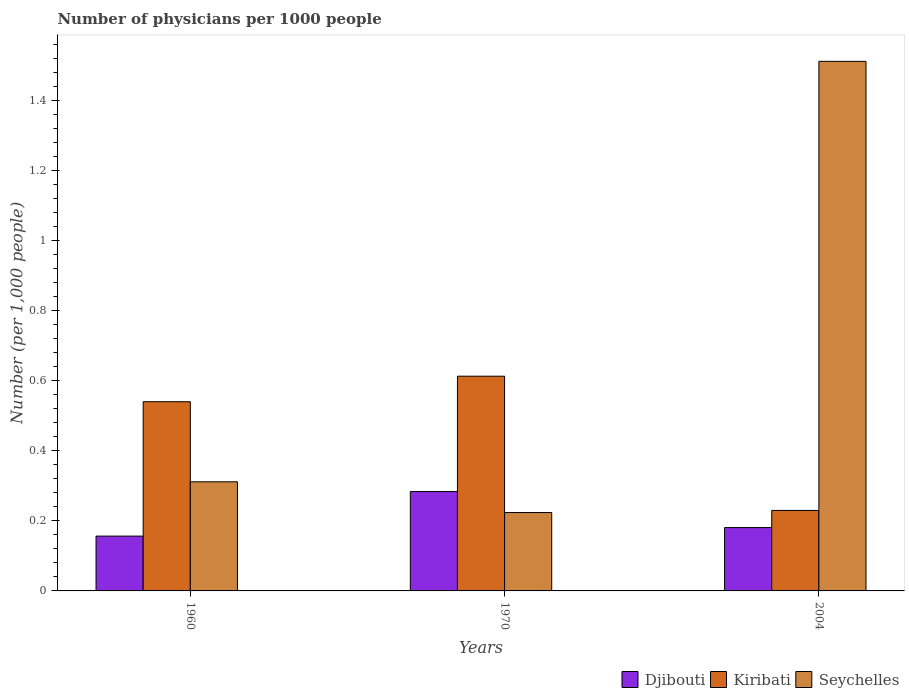How many different coloured bars are there?
Your answer should be compact. 3. How many groups of bars are there?
Provide a short and direct response. 3. Are the number of bars per tick equal to the number of legend labels?
Give a very brief answer. Yes. What is the label of the 3rd group of bars from the left?
Make the answer very short. 2004. What is the number of physicians in Seychelles in 1970?
Offer a terse response. 0.22. Across all years, what is the maximum number of physicians in Seychelles?
Provide a short and direct response. 1.51. Across all years, what is the minimum number of physicians in Seychelles?
Your response must be concise. 0.22. In which year was the number of physicians in Kiribati maximum?
Keep it short and to the point. 1970. What is the total number of physicians in Djibouti in the graph?
Make the answer very short. 0.62. What is the difference between the number of physicians in Kiribati in 1960 and that in 1970?
Offer a terse response. -0.07. What is the difference between the number of physicians in Djibouti in 1970 and the number of physicians in Kiribati in 2004?
Provide a succinct answer. 0.05. What is the average number of physicians in Djibouti per year?
Provide a short and direct response. 0.21. In the year 1970, what is the difference between the number of physicians in Seychelles and number of physicians in Kiribati?
Provide a short and direct response. -0.39. In how many years, is the number of physicians in Kiribati greater than 0.68?
Your response must be concise. 0. What is the ratio of the number of physicians in Seychelles in 1960 to that in 2004?
Your response must be concise. 0.21. Is the difference between the number of physicians in Seychelles in 1960 and 2004 greater than the difference between the number of physicians in Kiribati in 1960 and 2004?
Make the answer very short. No. What is the difference between the highest and the second highest number of physicians in Kiribati?
Your answer should be compact. 0.07. What is the difference between the highest and the lowest number of physicians in Seychelles?
Make the answer very short. 1.29. Is the sum of the number of physicians in Djibouti in 1970 and 2004 greater than the maximum number of physicians in Kiribati across all years?
Offer a very short reply. No. What does the 1st bar from the left in 1960 represents?
Provide a succinct answer. Djibouti. What does the 1st bar from the right in 1960 represents?
Your answer should be very brief. Seychelles. Is it the case that in every year, the sum of the number of physicians in Seychelles and number of physicians in Kiribati is greater than the number of physicians in Djibouti?
Give a very brief answer. Yes. Are all the bars in the graph horizontal?
Give a very brief answer. No. How many years are there in the graph?
Your answer should be very brief. 3. What is the difference between two consecutive major ticks on the Y-axis?
Provide a short and direct response. 0.2. Are the values on the major ticks of Y-axis written in scientific E-notation?
Your answer should be very brief. No. Does the graph contain any zero values?
Make the answer very short. No. Does the graph contain grids?
Your response must be concise. No. How many legend labels are there?
Provide a short and direct response. 3. How are the legend labels stacked?
Make the answer very short. Horizontal. What is the title of the graph?
Provide a succinct answer. Number of physicians per 1000 people. Does "World" appear as one of the legend labels in the graph?
Your answer should be compact. No. What is the label or title of the Y-axis?
Offer a very short reply. Number (per 1,0 people). What is the Number (per 1,000 people) in Djibouti in 1960?
Provide a short and direct response. 0.16. What is the Number (per 1,000 people) in Kiribati in 1960?
Ensure brevity in your answer.  0.54. What is the Number (per 1,000 people) of Seychelles in 1960?
Keep it short and to the point. 0.31. What is the Number (per 1,000 people) in Djibouti in 1970?
Offer a very short reply. 0.28. What is the Number (per 1,000 people) in Kiribati in 1970?
Your answer should be compact. 0.61. What is the Number (per 1,000 people) in Seychelles in 1970?
Give a very brief answer. 0.22. What is the Number (per 1,000 people) in Djibouti in 2004?
Offer a very short reply. 0.18. What is the Number (per 1,000 people) of Kiribati in 2004?
Give a very brief answer. 0.23. What is the Number (per 1,000 people) of Seychelles in 2004?
Provide a succinct answer. 1.51. Across all years, what is the maximum Number (per 1,000 people) in Djibouti?
Keep it short and to the point. 0.28. Across all years, what is the maximum Number (per 1,000 people) of Kiribati?
Keep it short and to the point. 0.61. Across all years, what is the maximum Number (per 1,000 people) in Seychelles?
Your answer should be compact. 1.51. Across all years, what is the minimum Number (per 1,000 people) of Djibouti?
Provide a succinct answer. 0.16. Across all years, what is the minimum Number (per 1,000 people) of Kiribati?
Your answer should be compact. 0.23. Across all years, what is the minimum Number (per 1,000 people) of Seychelles?
Give a very brief answer. 0.22. What is the total Number (per 1,000 people) of Djibouti in the graph?
Give a very brief answer. 0.62. What is the total Number (per 1,000 people) in Kiribati in the graph?
Your response must be concise. 1.38. What is the total Number (per 1,000 people) in Seychelles in the graph?
Offer a very short reply. 2.05. What is the difference between the Number (per 1,000 people) of Djibouti in 1960 and that in 1970?
Your answer should be very brief. -0.13. What is the difference between the Number (per 1,000 people) of Kiribati in 1960 and that in 1970?
Your response must be concise. -0.07. What is the difference between the Number (per 1,000 people) in Seychelles in 1960 and that in 1970?
Give a very brief answer. 0.09. What is the difference between the Number (per 1,000 people) of Djibouti in 1960 and that in 2004?
Ensure brevity in your answer.  -0.02. What is the difference between the Number (per 1,000 people) of Kiribati in 1960 and that in 2004?
Provide a short and direct response. 0.31. What is the difference between the Number (per 1,000 people) in Seychelles in 1960 and that in 2004?
Your answer should be compact. -1.2. What is the difference between the Number (per 1,000 people) in Djibouti in 1970 and that in 2004?
Ensure brevity in your answer.  0.1. What is the difference between the Number (per 1,000 people) of Kiribati in 1970 and that in 2004?
Make the answer very short. 0.38. What is the difference between the Number (per 1,000 people) in Seychelles in 1970 and that in 2004?
Offer a very short reply. -1.29. What is the difference between the Number (per 1,000 people) of Djibouti in 1960 and the Number (per 1,000 people) of Kiribati in 1970?
Make the answer very short. -0.46. What is the difference between the Number (per 1,000 people) in Djibouti in 1960 and the Number (per 1,000 people) in Seychelles in 1970?
Offer a very short reply. -0.07. What is the difference between the Number (per 1,000 people) in Kiribati in 1960 and the Number (per 1,000 people) in Seychelles in 1970?
Your response must be concise. 0.32. What is the difference between the Number (per 1,000 people) of Djibouti in 1960 and the Number (per 1,000 people) of Kiribati in 2004?
Your answer should be very brief. -0.07. What is the difference between the Number (per 1,000 people) in Djibouti in 1960 and the Number (per 1,000 people) in Seychelles in 2004?
Your response must be concise. -1.36. What is the difference between the Number (per 1,000 people) in Kiribati in 1960 and the Number (per 1,000 people) in Seychelles in 2004?
Provide a short and direct response. -0.97. What is the difference between the Number (per 1,000 people) of Djibouti in 1970 and the Number (per 1,000 people) of Kiribati in 2004?
Your response must be concise. 0.05. What is the difference between the Number (per 1,000 people) of Djibouti in 1970 and the Number (per 1,000 people) of Seychelles in 2004?
Make the answer very short. -1.23. What is the difference between the Number (per 1,000 people) of Kiribati in 1970 and the Number (per 1,000 people) of Seychelles in 2004?
Your answer should be very brief. -0.9. What is the average Number (per 1,000 people) in Djibouti per year?
Offer a very short reply. 0.21. What is the average Number (per 1,000 people) of Kiribati per year?
Provide a short and direct response. 0.46. What is the average Number (per 1,000 people) of Seychelles per year?
Make the answer very short. 0.68. In the year 1960, what is the difference between the Number (per 1,000 people) in Djibouti and Number (per 1,000 people) in Kiribati?
Ensure brevity in your answer.  -0.38. In the year 1960, what is the difference between the Number (per 1,000 people) in Djibouti and Number (per 1,000 people) in Seychelles?
Offer a terse response. -0.16. In the year 1960, what is the difference between the Number (per 1,000 people) in Kiribati and Number (per 1,000 people) in Seychelles?
Keep it short and to the point. 0.23. In the year 1970, what is the difference between the Number (per 1,000 people) of Djibouti and Number (per 1,000 people) of Kiribati?
Your answer should be compact. -0.33. In the year 1970, what is the difference between the Number (per 1,000 people) of Djibouti and Number (per 1,000 people) of Seychelles?
Offer a very short reply. 0.06. In the year 1970, what is the difference between the Number (per 1,000 people) in Kiribati and Number (per 1,000 people) in Seychelles?
Offer a terse response. 0.39. In the year 2004, what is the difference between the Number (per 1,000 people) of Djibouti and Number (per 1,000 people) of Kiribati?
Your answer should be very brief. -0.05. In the year 2004, what is the difference between the Number (per 1,000 people) of Djibouti and Number (per 1,000 people) of Seychelles?
Provide a succinct answer. -1.33. In the year 2004, what is the difference between the Number (per 1,000 people) of Kiribati and Number (per 1,000 people) of Seychelles?
Provide a succinct answer. -1.28. What is the ratio of the Number (per 1,000 people) of Djibouti in 1960 to that in 1970?
Your answer should be very brief. 0.55. What is the ratio of the Number (per 1,000 people) of Kiribati in 1960 to that in 1970?
Ensure brevity in your answer.  0.88. What is the ratio of the Number (per 1,000 people) in Seychelles in 1960 to that in 1970?
Keep it short and to the point. 1.39. What is the ratio of the Number (per 1,000 people) of Djibouti in 1960 to that in 2004?
Keep it short and to the point. 0.87. What is the ratio of the Number (per 1,000 people) in Kiribati in 1960 to that in 2004?
Provide a succinct answer. 2.35. What is the ratio of the Number (per 1,000 people) in Seychelles in 1960 to that in 2004?
Give a very brief answer. 0.21. What is the ratio of the Number (per 1,000 people) in Djibouti in 1970 to that in 2004?
Provide a succinct answer. 1.57. What is the ratio of the Number (per 1,000 people) in Kiribati in 1970 to that in 2004?
Provide a short and direct response. 2.67. What is the ratio of the Number (per 1,000 people) of Seychelles in 1970 to that in 2004?
Provide a succinct answer. 0.15. What is the difference between the highest and the second highest Number (per 1,000 people) of Djibouti?
Provide a succinct answer. 0.1. What is the difference between the highest and the second highest Number (per 1,000 people) in Kiribati?
Keep it short and to the point. 0.07. What is the difference between the highest and the second highest Number (per 1,000 people) of Seychelles?
Offer a terse response. 1.2. What is the difference between the highest and the lowest Number (per 1,000 people) of Djibouti?
Provide a succinct answer. 0.13. What is the difference between the highest and the lowest Number (per 1,000 people) in Kiribati?
Keep it short and to the point. 0.38. What is the difference between the highest and the lowest Number (per 1,000 people) in Seychelles?
Make the answer very short. 1.29. 